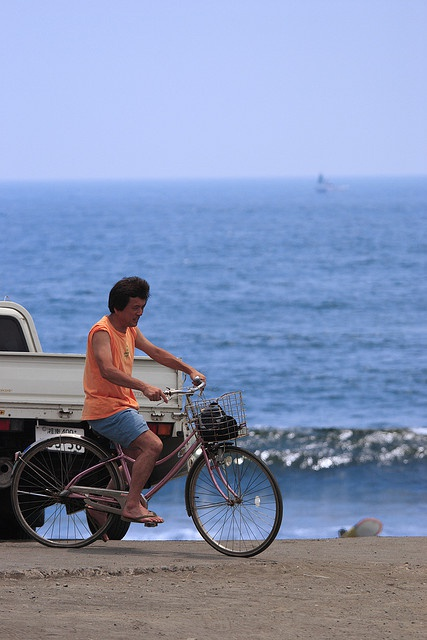Describe the objects in this image and their specific colors. I can see bicycle in lavender, black, gray, and darkgray tones, truck in lavender, black, darkgray, gray, and maroon tones, people in lavender, maroon, black, and brown tones, handbag in lavender, black, and gray tones, and surfboard in lavender and gray tones in this image. 